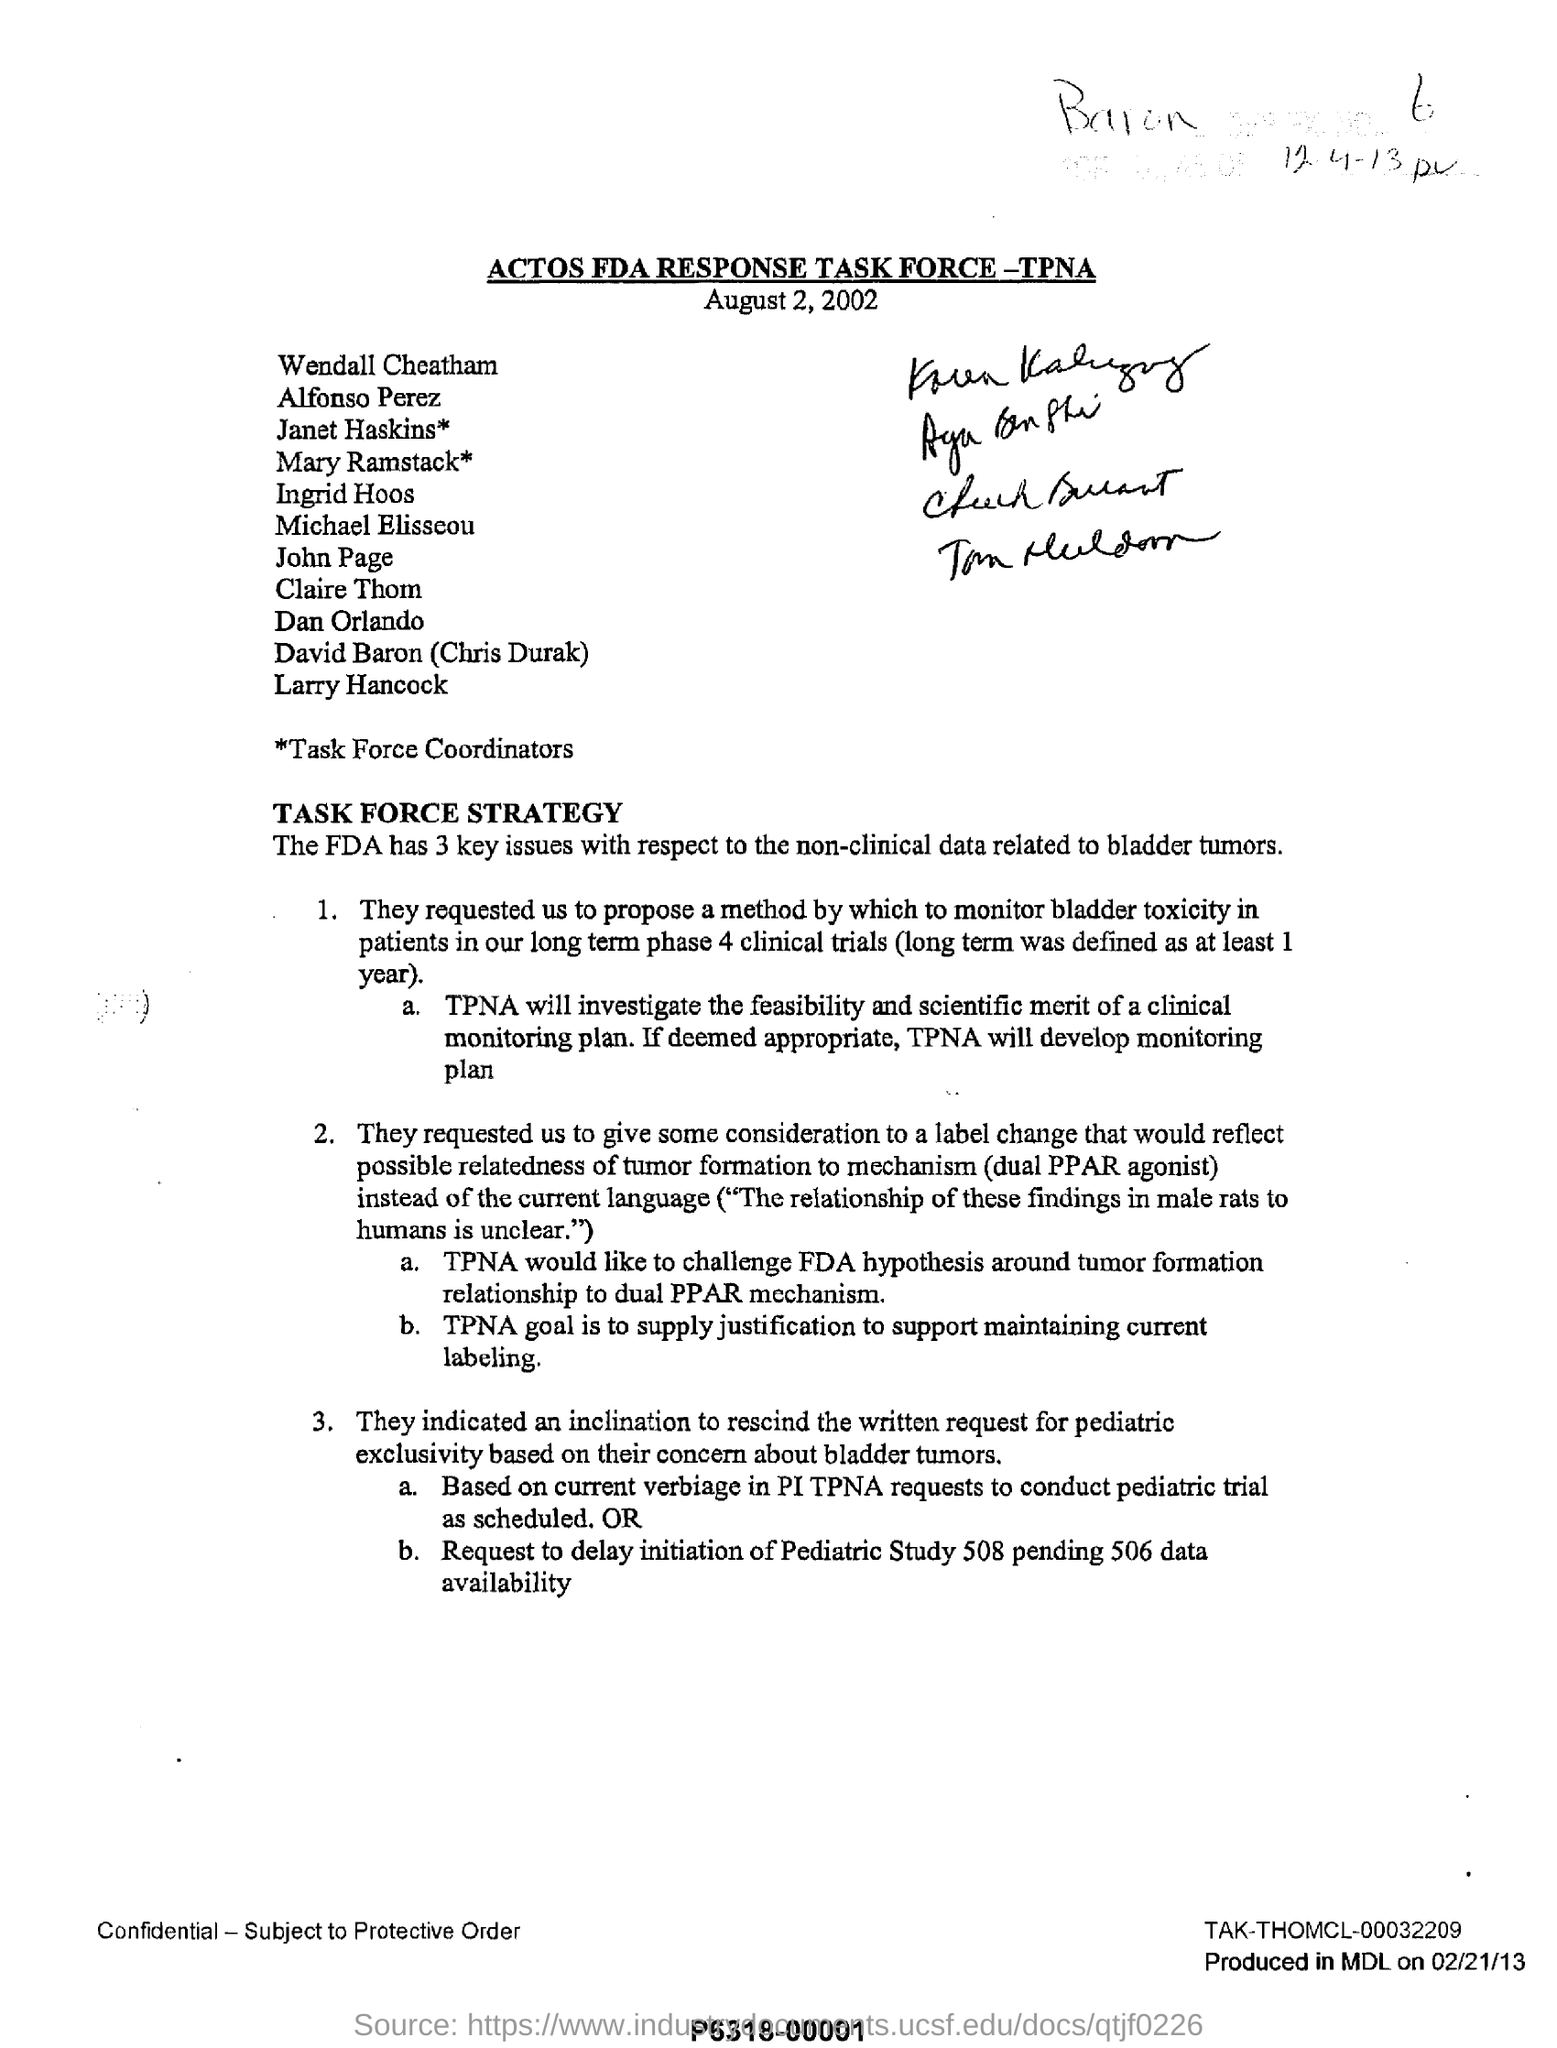Mention a couple of crucial points in this snapshot. TPNA's goal is to provide justification for maintaining current labeling practices. The FDA has identified three key issues with respect to the non-clinical data related to bladder tumors. The heading of the document is "ACTOS FDA RESPONSE TASK FORCE-TPNA. TPNA has developed a monitoring plan. 